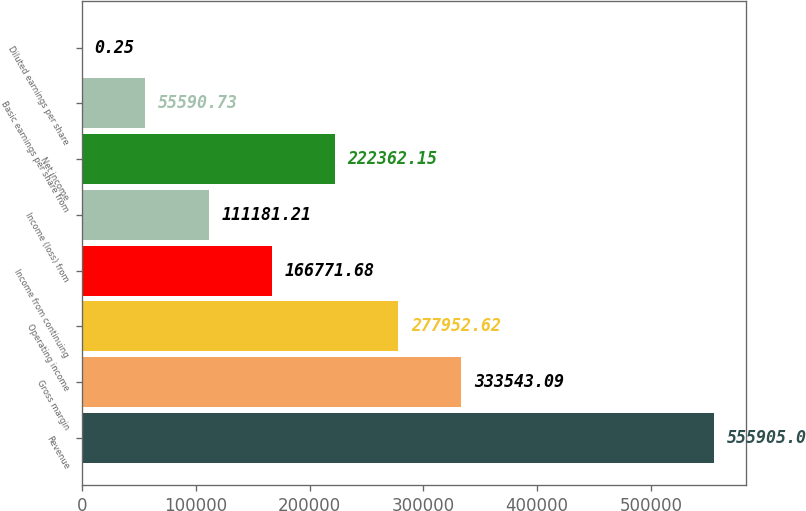Convert chart. <chart><loc_0><loc_0><loc_500><loc_500><bar_chart><fcel>Revenue<fcel>Gross margin<fcel>Operating income<fcel>Income from continuing<fcel>Income (loss) from<fcel>Net income<fcel>Basic earnings per share from<fcel>Diluted earnings per share<nl><fcel>555905<fcel>333543<fcel>277953<fcel>166772<fcel>111181<fcel>222362<fcel>55590.7<fcel>0.25<nl></chart> 